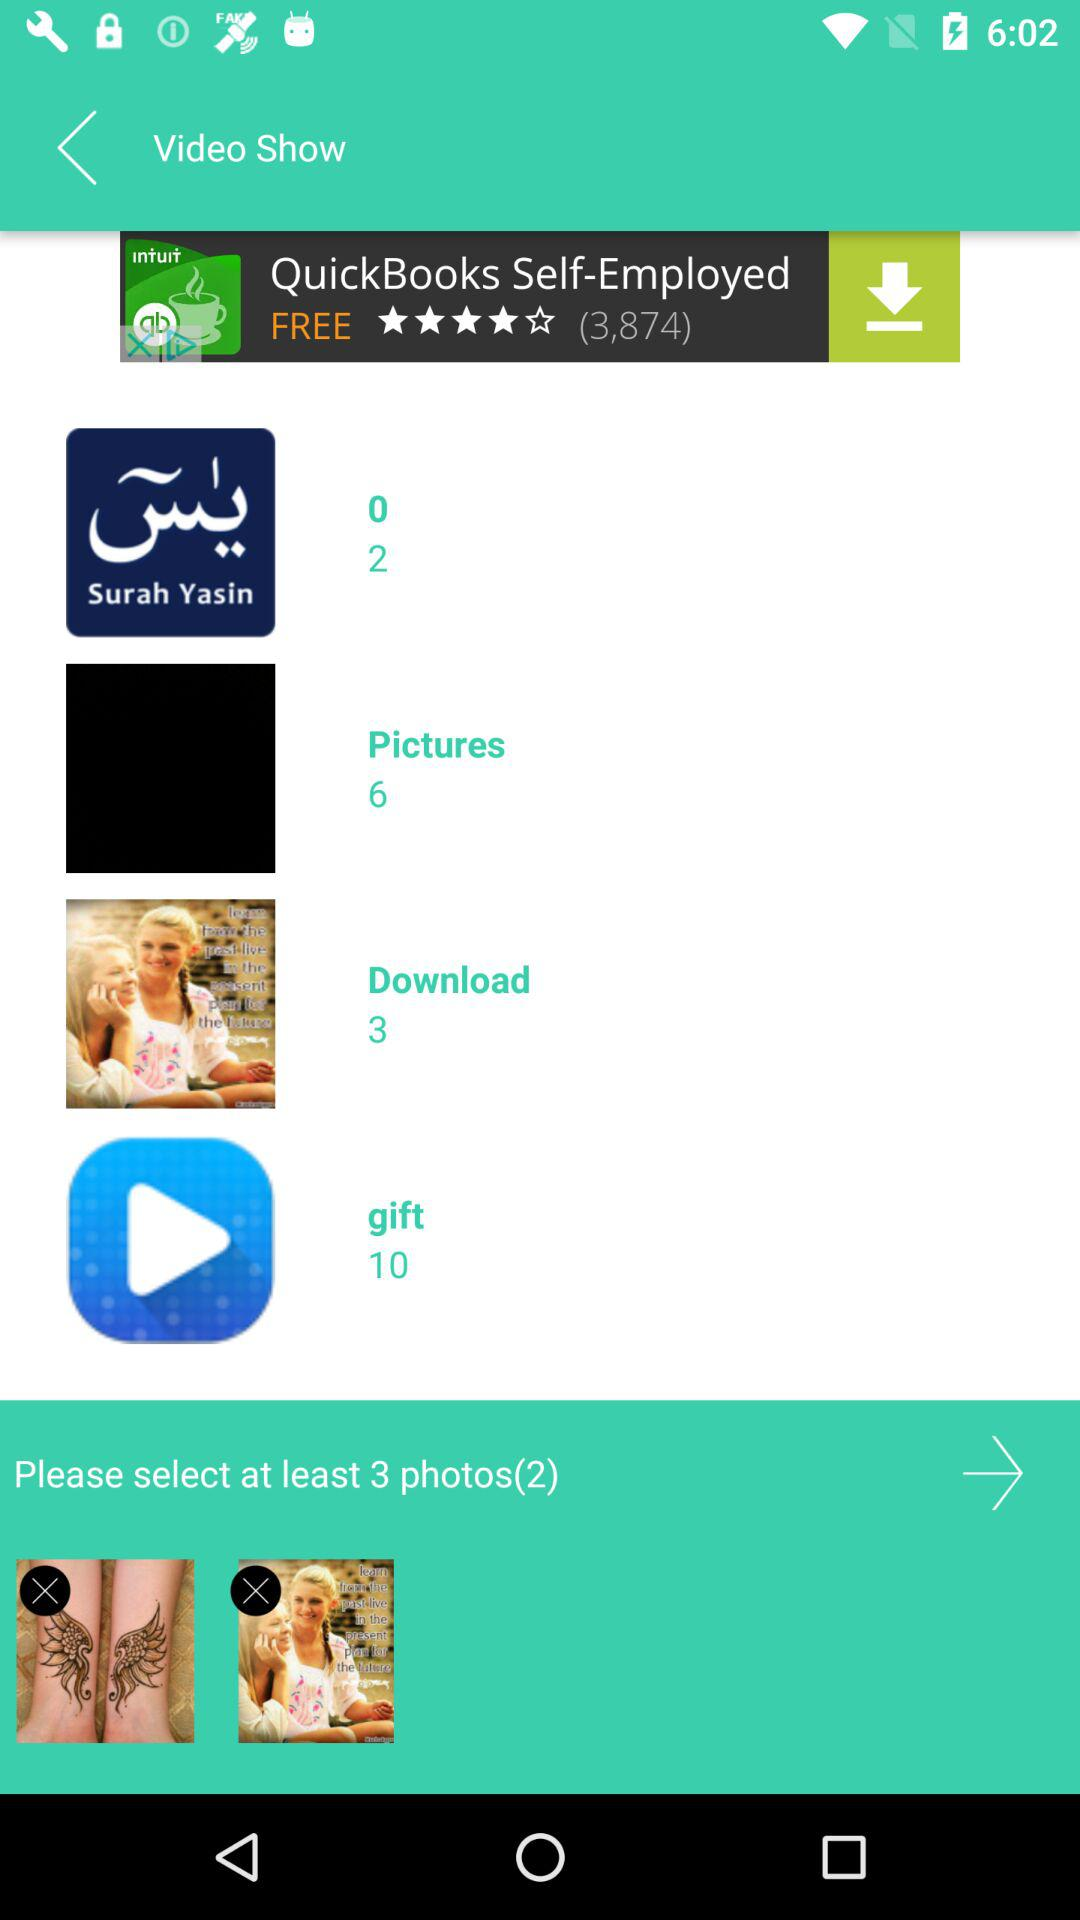Through which applications can this be shared?
When the provided information is insufficient, respond with <no answer>. <no answer> 